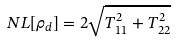Convert formula to latex. <formula><loc_0><loc_0><loc_500><loc_500>N L [ \rho _ { d } ] = 2 \sqrt { T _ { 1 1 } ^ { 2 } + T _ { 2 2 } ^ { 2 } }</formula> 